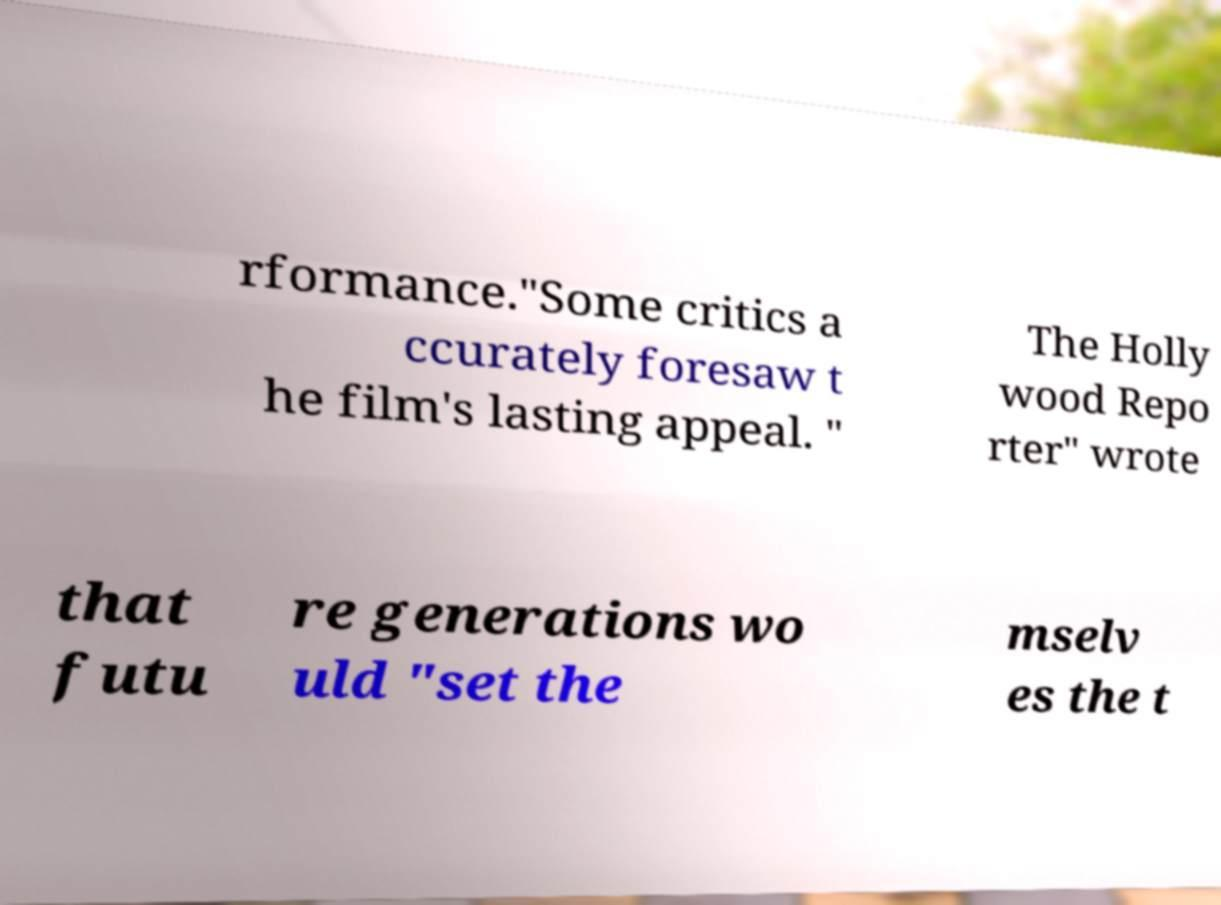Could you extract and type out the text from this image? rformance."Some critics a ccurately foresaw t he film's lasting appeal. " The Holly wood Repo rter" wrote that futu re generations wo uld "set the mselv es the t 